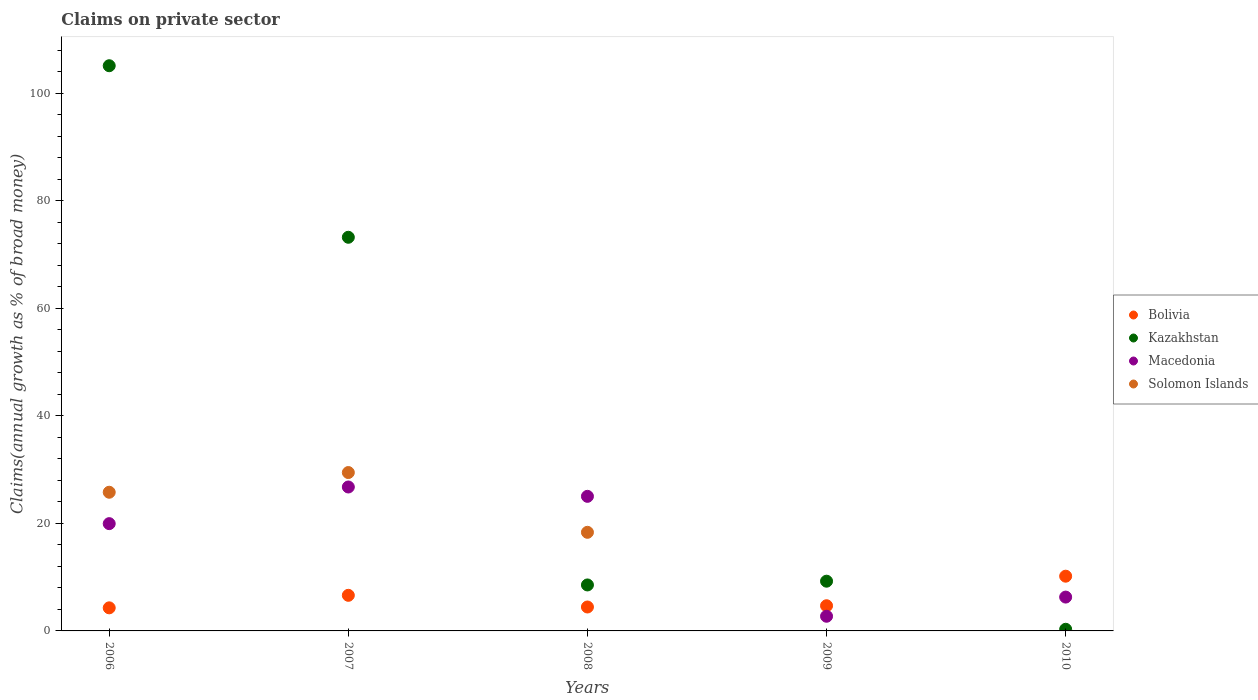How many different coloured dotlines are there?
Keep it short and to the point. 4. What is the percentage of broad money claimed on private sector in Solomon Islands in 2008?
Make the answer very short. 18.35. Across all years, what is the maximum percentage of broad money claimed on private sector in Macedonia?
Give a very brief answer. 26.78. Across all years, what is the minimum percentage of broad money claimed on private sector in Kazakhstan?
Your response must be concise. 0.31. What is the total percentage of broad money claimed on private sector in Solomon Islands in the graph?
Offer a terse response. 73.61. What is the difference between the percentage of broad money claimed on private sector in Macedonia in 2006 and that in 2008?
Your answer should be very brief. -5.08. What is the difference between the percentage of broad money claimed on private sector in Macedonia in 2006 and the percentage of broad money claimed on private sector in Kazakhstan in 2008?
Your response must be concise. 11.41. What is the average percentage of broad money claimed on private sector in Macedonia per year?
Give a very brief answer. 16.16. In the year 2007, what is the difference between the percentage of broad money claimed on private sector in Macedonia and percentage of broad money claimed on private sector in Kazakhstan?
Keep it short and to the point. -46.46. In how many years, is the percentage of broad money claimed on private sector in Solomon Islands greater than 16 %?
Make the answer very short. 3. What is the ratio of the percentage of broad money claimed on private sector in Kazakhstan in 2007 to that in 2008?
Your response must be concise. 8.56. What is the difference between the highest and the second highest percentage of broad money claimed on private sector in Kazakhstan?
Your response must be concise. 31.92. What is the difference between the highest and the lowest percentage of broad money claimed on private sector in Kazakhstan?
Provide a succinct answer. 104.85. Is the sum of the percentage of broad money claimed on private sector in Macedonia in 2007 and 2010 greater than the maximum percentage of broad money claimed on private sector in Kazakhstan across all years?
Your answer should be compact. No. Is it the case that in every year, the sum of the percentage of broad money claimed on private sector in Macedonia and percentage of broad money claimed on private sector in Solomon Islands  is greater than the sum of percentage of broad money claimed on private sector in Kazakhstan and percentage of broad money claimed on private sector in Bolivia?
Offer a terse response. No. Does the percentage of broad money claimed on private sector in Bolivia monotonically increase over the years?
Your answer should be compact. No. How many dotlines are there?
Give a very brief answer. 4. How many years are there in the graph?
Provide a succinct answer. 5. Are the values on the major ticks of Y-axis written in scientific E-notation?
Provide a succinct answer. No. Does the graph contain any zero values?
Your response must be concise. Yes. Where does the legend appear in the graph?
Your response must be concise. Center right. How many legend labels are there?
Keep it short and to the point. 4. How are the legend labels stacked?
Keep it short and to the point. Vertical. What is the title of the graph?
Your answer should be very brief. Claims on private sector. What is the label or title of the Y-axis?
Your answer should be compact. Claims(annual growth as % of broad money). What is the Claims(annual growth as % of broad money) in Bolivia in 2006?
Your answer should be compact. 4.29. What is the Claims(annual growth as % of broad money) of Kazakhstan in 2006?
Your response must be concise. 105.15. What is the Claims(annual growth as % of broad money) of Macedonia in 2006?
Your answer should be very brief. 19.96. What is the Claims(annual growth as % of broad money) of Solomon Islands in 2006?
Make the answer very short. 25.8. What is the Claims(annual growth as % of broad money) of Bolivia in 2007?
Give a very brief answer. 6.62. What is the Claims(annual growth as % of broad money) in Kazakhstan in 2007?
Provide a succinct answer. 73.24. What is the Claims(annual growth as % of broad money) in Macedonia in 2007?
Ensure brevity in your answer.  26.78. What is the Claims(annual growth as % of broad money) of Solomon Islands in 2007?
Your response must be concise. 29.47. What is the Claims(annual growth as % of broad money) in Bolivia in 2008?
Your answer should be very brief. 4.45. What is the Claims(annual growth as % of broad money) of Kazakhstan in 2008?
Offer a terse response. 8.55. What is the Claims(annual growth as % of broad money) in Macedonia in 2008?
Offer a very short reply. 25.04. What is the Claims(annual growth as % of broad money) in Solomon Islands in 2008?
Give a very brief answer. 18.35. What is the Claims(annual growth as % of broad money) of Bolivia in 2009?
Your answer should be compact. 4.69. What is the Claims(annual growth as % of broad money) of Kazakhstan in 2009?
Your response must be concise. 9.25. What is the Claims(annual growth as % of broad money) of Macedonia in 2009?
Provide a short and direct response. 2.73. What is the Claims(annual growth as % of broad money) in Solomon Islands in 2009?
Your response must be concise. 0. What is the Claims(annual growth as % of broad money) of Bolivia in 2010?
Keep it short and to the point. 10.18. What is the Claims(annual growth as % of broad money) in Kazakhstan in 2010?
Ensure brevity in your answer.  0.31. What is the Claims(annual growth as % of broad money) in Macedonia in 2010?
Keep it short and to the point. 6.3. What is the Claims(annual growth as % of broad money) of Solomon Islands in 2010?
Make the answer very short. 0. Across all years, what is the maximum Claims(annual growth as % of broad money) in Bolivia?
Offer a terse response. 10.18. Across all years, what is the maximum Claims(annual growth as % of broad money) of Kazakhstan?
Keep it short and to the point. 105.15. Across all years, what is the maximum Claims(annual growth as % of broad money) in Macedonia?
Offer a very short reply. 26.78. Across all years, what is the maximum Claims(annual growth as % of broad money) in Solomon Islands?
Provide a short and direct response. 29.47. Across all years, what is the minimum Claims(annual growth as % of broad money) of Bolivia?
Provide a succinct answer. 4.29. Across all years, what is the minimum Claims(annual growth as % of broad money) of Kazakhstan?
Your answer should be very brief. 0.31. Across all years, what is the minimum Claims(annual growth as % of broad money) in Macedonia?
Your answer should be compact. 2.73. Across all years, what is the minimum Claims(annual growth as % of broad money) of Solomon Islands?
Your response must be concise. 0. What is the total Claims(annual growth as % of broad money) of Bolivia in the graph?
Your response must be concise. 30.24. What is the total Claims(annual growth as % of broad money) of Kazakhstan in the graph?
Provide a succinct answer. 196.5. What is the total Claims(annual growth as % of broad money) of Macedonia in the graph?
Keep it short and to the point. 80.8. What is the total Claims(annual growth as % of broad money) of Solomon Islands in the graph?
Offer a terse response. 73.61. What is the difference between the Claims(annual growth as % of broad money) of Bolivia in 2006 and that in 2007?
Your response must be concise. -2.33. What is the difference between the Claims(annual growth as % of broad money) in Kazakhstan in 2006 and that in 2007?
Ensure brevity in your answer.  31.92. What is the difference between the Claims(annual growth as % of broad money) of Macedonia in 2006 and that in 2007?
Offer a very short reply. -6.82. What is the difference between the Claims(annual growth as % of broad money) in Solomon Islands in 2006 and that in 2007?
Your answer should be very brief. -3.66. What is the difference between the Claims(annual growth as % of broad money) of Bolivia in 2006 and that in 2008?
Your answer should be compact. -0.16. What is the difference between the Claims(annual growth as % of broad money) of Kazakhstan in 2006 and that in 2008?
Offer a very short reply. 96.6. What is the difference between the Claims(annual growth as % of broad money) of Macedonia in 2006 and that in 2008?
Provide a succinct answer. -5.08. What is the difference between the Claims(annual growth as % of broad money) in Solomon Islands in 2006 and that in 2008?
Your response must be concise. 7.45. What is the difference between the Claims(annual growth as % of broad money) of Bolivia in 2006 and that in 2009?
Ensure brevity in your answer.  -0.39. What is the difference between the Claims(annual growth as % of broad money) of Kazakhstan in 2006 and that in 2009?
Your response must be concise. 95.9. What is the difference between the Claims(annual growth as % of broad money) in Macedonia in 2006 and that in 2009?
Provide a succinct answer. 17.23. What is the difference between the Claims(annual growth as % of broad money) of Bolivia in 2006 and that in 2010?
Provide a short and direct response. -5.89. What is the difference between the Claims(annual growth as % of broad money) of Kazakhstan in 2006 and that in 2010?
Your response must be concise. 104.85. What is the difference between the Claims(annual growth as % of broad money) of Macedonia in 2006 and that in 2010?
Offer a terse response. 13.66. What is the difference between the Claims(annual growth as % of broad money) of Bolivia in 2007 and that in 2008?
Offer a very short reply. 2.17. What is the difference between the Claims(annual growth as % of broad money) of Kazakhstan in 2007 and that in 2008?
Give a very brief answer. 64.68. What is the difference between the Claims(annual growth as % of broad money) in Macedonia in 2007 and that in 2008?
Your response must be concise. 1.74. What is the difference between the Claims(annual growth as % of broad money) of Solomon Islands in 2007 and that in 2008?
Provide a succinct answer. 11.12. What is the difference between the Claims(annual growth as % of broad money) of Bolivia in 2007 and that in 2009?
Offer a very short reply. 1.94. What is the difference between the Claims(annual growth as % of broad money) in Kazakhstan in 2007 and that in 2009?
Provide a short and direct response. 63.98. What is the difference between the Claims(annual growth as % of broad money) in Macedonia in 2007 and that in 2009?
Keep it short and to the point. 24.05. What is the difference between the Claims(annual growth as % of broad money) in Bolivia in 2007 and that in 2010?
Offer a very short reply. -3.56. What is the difference between the Claims(annual growth as % of broad money) in Kazakhstan in 2007 and that in 2010?
Provide a short and direct response. 72.93. What is the difference between the Claims(annual growth as % of broad money) of Macedonia in 2007 and that in 2010?
Give a very brief answer. 20.48. What is the difference between the Claims(annual growth as % of broad money) of Bolivia in 2008 and that in 2009?
Your answer should be very brief. -0.24. What is the difference between the Claims(annual growth as % of broad money) of Kazakhstan in 2008 and that in 2009?
Ensure brevity in your answer.  -0.7. What is the difference between the Claims(annual growth as % of broad money) in Macedonia in 2008 and that in 2009?
Your response must be concise. 22.31. What is the difference between the Claims(annual growth as % of broad money) of Bolivia in 2008 and that in 2010?
Ensure brevity in your answer.  -5.73. What is the difference between the Claims(annual growth as % of broad money) in Kazakhstan in 2008 and that in 2010?
Provide a succinct answer. 8.25. What is the difference between the Claims(annual growth as % of broad money) of Macedonia in 2008 and that in 2010?
Offer a terse response. 18.74. What is the difference between the Claims(annual growth as % of broad money) in Bolivia in 2009 and that in 2010?
Your response must be concise. -5.5. What is the difference between the Claims(annual growth as % of broad money) of Kazakhstan in 2009 and that in 2010?
Provide a short and direct response. 8.95. What is the difference between the Claims(annual growth as % of broad money) in Macedonia in 2009 and that in 2010?
Keep it short and to the point. -3.57. What is the difference between the Claims(annual growth as % of broad money) in Bolivia in 2006 and the Claims(annual growth as % of broad money) in Kazakhstan in 2007?
Make the answer very short. -68.94. What is the difference between the Claims(annual growth as % of broad money) in Bolivia in 2006 and the Claims(annual growth as % of broad money) in Macedonia in 2007?
Provide a short and direct response. -22.48. What is the difference between the Claims(annual growth as % of broad money) in Bolivia in 2006 and the Claims(annual growth as % of broad money) in Solomon Islands in 2007?
Your answer should be compact. -25.17. What is the difference between the Claims(annual growth as % of broad money) of Kazakhstan in 2006 and the Claims(annual growth as % of broad money) of Macedonia in 2007?
Your answer should be compact. 78.38. What is the difference between the Claims(annual growth as % of broad money) in Kazakhstan in 2006 and the Claims(annual growth as % of broad money) in Solomon Islands in 2007?
Keep it short and to the point. 75.69. What is the difference between the Claims(annual growth as % of broad money) of Macedonia in 2006 and the Claims(annual growth as % of broad money) of Solomon Islands in 2007?
Your answer should be very brief. -9.51. What is the difference between the Claims(annual growth as % of broad money) in Bolivia in 2006 and the Claims(annual growth as % of broad money) in Kazakhstan in 2008?
Offer a very short reply. -4.26. What is the difference between the Claims(annual growth as % of broad money) in Bolivia in 2006 and the Claims(annual growth as % of broad money) in Macedonia in 2008?
Offer a very short reply. -20.75. What is the difference between the Claims(annual growth as % of broad money) of Bolivia in 2006 and the Claims(annual growth as % of broad money) of Solomon Islands in 2008?
Your answer should be compact. -14.05. What is the difference between the Claims(annual growth as % of broad money) in Kazakhstan in 2006 and the Claims(annual growth as % of broad money) in Macedonia in 2008?
Ensure brevity in your answer.  80.11. What is the difference between the Claims(annual growth as % of broad money) in Kazakhstan in 2006 and the Claims(annual growth as % of broad money) in Solomon Islands in 2008?
Your answer should be very brief. 86.81. What is the difference between the Claims(annual growth as % of broad money) in Macedonia in 2006 and the Claims(annual growth as % of broad money) in Solomon Islands in 2008?
Make the answer very short. 1.61. What is the difference between the Claims(annual growth as % of broad money) of Bolivia in 2006 and the Claims(annual growth as % of broad money) of Kazakhstan in 2009?
Keep it short and to the point. -4.96. What is the difference between the Claims(annual growth as % of broad money) of Bolivia in 2006 and the Claims(annual growth as % of broad money) of Macedonia in 2009?
Provide a short and direct response. 1.56. What is the difference between the Claims(annual growth as % of broad money) of Kazakhstan in 2006 and the Claims(annual growth as % of broad money) of Macedonia in 2009?
Your answer should be very brief. 102.42. What is the difference between the Claims(annual growth as % of broad money) in Bolivia in 2006 and the Claims(annual growth as % of broad money) in Kazakhstan in 2010?
Your answer should be compact. 3.99. What is the difference between the Claims(annual growth as % of broad money) in Bolivia in 2006 and the Claims(annual growth as % of broad money) in Macedonia in 2010?
Offer a very short reply. -2. What is the difference between the Claims(annual growth as % of broad money) of Kazakhstan in 2006 and the Claims(annual growth as % of broad money) of Macedonia in 2010?
Keep it short and to the point. 98.86. What is the difference between the Claims(annual growth as % of broad money) in Bolivia in 2007 and the Claims(annual growth as % of broad money) in Kazakhstan in 2008?
Provide a short and direct response. -1.93. What is the difference between the Claims(annual growth as % of broad money) in Bolivia in 2007 and the Claims(annual growth as % of broad money) in Macedonia in 2008?
Give a very brief answer. -18.42. What is the difference between the Claims(annual growth as % of broad money) in Bolivia in 2007 and the Claims(annual growth as % of broad money) in Solomon Islands in 2008?
Your answer should be very brief. -11.72. What is the difference between the Claims(annual growth as % of broad money) of Kazakhstan in 2007 and the Claims(annual growth as % of broad money) of Macedonia in 2008?
Give a very brief answer. 48.2. What is the difference between the Claims(annual growth as % of broad money) of Kazakhstan in 2007 and the Claims(annual growth as % of broad money) of Solomon Islands in 2008?
Ensure brevity in your answer.  54.89. What is the difference between the Claims(annual growth as % of broad money) in Macedonia in 2007 and the Claims(annual growth as % of broad money) in Solomon Islands in 2008?
Your answer should be compact. 8.43. What is the difference between the Claims(annual growth as % of broad money) of Bolivia in 2007 and the Claims(annual growth as % of broad money) of Kazakhstan in 2009?
Give a very brief answer. -2.63. What is the difference between the Claims(annual growth as % of broad money) in Bolivia in 2007 and the Claims(annual growth as % of broad money) in Macedonia in 2009?
Your response must be concise. 3.89. What is the difference between the Claims(annual growth as % of broad money) of Kazakhstan in 2007 and the Claims(annual growth as % of broad money) of Macedonia in 2009?
Provide a succinct answer. 70.51. What is the difference between the Claims(annual growth as % of broad money) in Bolivia in 2007 and the Claims(annual growth as % of broad money) in Kazakhstan in 2010?
Provide a short and direct response. 6.32. What is the difference between the Claims(annual growth as % of broad money) of Bolivia in 2007 and the Claims(annual growth as % of broad money) of Macedonia in 2010?
Keep it short and to the point. 0.33. What is the difference between the Claims(annual growth as % of broad money) of Kazakhstan in 2007 and the Claims(annual growth as % of broad money) of Macedonia in 2010?
Your answer should be very brief. 66.94. What is the difference between the Claims(annual growth as % of broad money) in Bolivia in 2008 and the Claims(annual growth as % of broad money) in Kazakhstan in 2009?
Offer a very short reply. -4.8. What is the difference between the Claims(annual growth as % of broad money) in Bolivia in 2008 and the Claims(annual growth as % of broad money) in Macedonia in 2009?
Give a very brief answer. 1.72. What is the difference between the Claims(annual growth as % of broad money) in Kazakhstan in 2008 and the Claims(annual growth as % of broad money) in Macedonia in 2009?
Offer a terse response. 5.82. What is the difference between the Claims(annual growth as % of broad money) of Bolivia in 2008 and the Claims(annual growth as % of broad money) of Kazakhstan in 2010?
Make the answer very short. 4.15. What is the difference between the Claims(annual growth as % of broad money) in Bolivia in 2008 and the Claims(annual growth as % of broad money) in Macedonia in 2010?
Provide a short and direct response. -1.85. What is the difference between the Claims(annual growth as % of broad money) of Kazakhstan in 2008 and the Claims(annual growth as % of broad money) of Macedonia in 2010?
Your answer should be very brief. 2.26. What is the difference between the Claims(annual growth as % of broad money) in Bolivia in 2009 and the Claims(annual growth as % of broad money) in Kazakhstan in 2010?
Your answer should be compact. 4.38. What is the difference between the Claims(annual growth as % of broad money) of Bolivia in 2009 and the Claims(annual growth as % of broad money) of Macedonia in 2010?
Give a very brief answer. -1.61. What is the difference between the Claims(annual growth as % of broad money) of Kazakhstan in 2009 and the Claims(annual growth as % of broad money) of Macedonia in 2010?
Provide a short and direct response. 2.96. What is the average Claims(annual growth as % of broad money) of Bolivia per year?
Offer a very short reply. 6.05. What is the average Claims(annual growth as % of broad money) in Kazakhstan per year?
Ensure brevity in your answer.  39.3. What is the average Claims(annual growth as % of broad money) of Macedonia per year?
Your answer should be compact. 16.16. What is the average Claims(annual growth as % of broad money) of Solomon Islands per year?
Your answer should be compact. 14.72. In the year 2006, what is the difference between the Claims(annual growth as % of broad money) of Bolivia and Claims(annual growth as % of broad money) of Kazakhstan?
Your response must be concise. -100.86. In the year 2006, what is the difference between the Claims(annual growth as % of broad money) of Bolivia and Claims(annual growth as % of broad money) of Macedonia?
Ensure brevity in your answer.  -15.66. In the year 2006, what is the difference between the Claims(annual growth as % of broad money) in Bolivia and Claims(annual growth as % of broad money) in Solomon Islands?
Give a very brief answer. -21.51. In the year 2006, what is the difference between the Claims(annual growth as % of broad money) in Kazakhstan and Claims(annual growth as % of broad money) in Macedonia?
Give a very brief answer. 85.19. In the year 2006, what is the difference between the Claims(annual growth as % of broad money) in Kazakhstan and Claims(annual growth as % of broad money) in Solomon Islands?
Your answer should be compact. 79.35. In the year 2006, what is the difference between the Claims(annual growth as % of broad money) of Macedonia and Claims(annual growth as % of broad money) of Solomon Islands?
Give a very brief answer. -5.84. In the year 2007, what is the difference between the Claims(annual growth as % of broad money) in Bolivia and Claims(annual growth as % of broad money) in Kazakhstan?
Your answer should be compact. -66.61. In the year 2007, what is the difference between the Claims(annual growth as % of broad money) in Bolivia and Claims(annual growth as % of broad money) in Macedonia?
Offer a terse response. -20.15. In the year 2007, what is the difference between the Claims(annual growth as % of broad money) in Bolivia and Claims(annual growth as % of broad money) in Solomon Islands?
Your response must be concise. -22.84. In the year 2007, what is the difference between the Claims(annual growth as % of broad money) in Kazakhstan and Claims(annual growth as % of broad money) in Macedonia?
Your answer should be compact. 46.46. In the year 2007, what is the difference between the Claims(annual growth as % of broad money) in Kazakhstan and Claims(annual growth as % of broad money) in Solomon Islands?
Your answer should be very brief. 43.77. In the year 2007, what is the difference between the Claims(annual growth as % of broad money) in Macedonia and Claims(annual growth as % of broad money) in Solomon Islands?
Offer a terse response. -2.69. In the year 2008, what is the difference between the Claims(annual growth as % of broad money) of Bolivia and Claims(annual growth as % of broad money) of Kazakhstan?
Make the answer very short. -4.1. In the year 2008, what is the difference between the Claims(annual growth as % of broad money) in Bolivia and Claims(annual growth as % of broad money) in Macedonia?
Keep it short and to the point. -20.59. In the year 2008, what is the difference between the Claims(annual growth as % of broad money) in Bolivia and Claims(annual growth as % of broad money) in Solomon Islands?
Your response must be concise. -13.9. In the year 2008, what is the difference between the Claims(annual growth as % of broad money) in Kazakhstan and Claims(annual growth as % of broad money) in Macedonia?
Your answer should be compact. -16.49. In the year 2008, what is the difference between the Claims(annual growth as % of broad money) in Kazakhstan and Claims(annual growth as % of broad money) in Solomon Islands?
Provide a succinct answer. -9.79. In the year 2008, what is the difference between the Claims(annual growth as % of broad money) of Macedonia and Claims(annual growth as % of broad money) of Solomon Islands?
Give a very brief answer. 6.69. In the year 2009, what is the difference between the Claims(annual growth as % of broad money) of Bolivia and Claims(annual growth as % of broad money) of Kazakhstan?
Ensure brevity in your answer.  -4.57. In the year 2009, what is the difference between the Claims(annual growth as % of broad money) of Bolivia and Claims(annual growth as % of broad money) of Macedonia?
Keep it short and to the point. 1.96. In the year 2009, what is the difference between the Claims(annual growth as % of broad money) in Kazakhstan and Claims(annual growth as % of broad money) in Macedonia?
Your answer should be very brief. 6.52. In the year 2010, what is the difference between the Claims(annual growth as % of broad money) in Bolivia and Claims(annual growth as % of broad money) in Kazakhstan?
Provide a succinct answer. 9.88. In the year 2010, what is the difference between the Claims(annual growth as % of broad money) of Bolivia and Claims(annual growth as % of broad money) of Macedonia?
Your answer should be compact. 3.89. In the year 2010, what is the difference between the Claims(annual growth as % of broad money) of Kazakhstan and Claims(annual growth as % of broad money) of Macedonia?
Provide a succinct answer. -5.99. What is the ratio of the Claims(annual growth as % of broad money) in Bolivia in 2006 to that in 2007?
Offer a very short reply. 0.65. What is the ratio of the Claims(annual growth as % of broad money) of Kazakhstan in 2006 to that in 2007?
Give a very brief answer. 1.44. What is the ratio of the Claims(annual growth as % of broad money) of Macedonia in 2006 to that in 2007?
Your answer should be compact. 0.75. What is the ratio of the Claims(annual growth as % of broad money) of Solomon Islands in 2006 to that in 2007?
Provide a short and direct response. 0.88. What is the ratio of the Claims(annual growth as % of broad money) in Bolivia in 2006 to that in 2008?
Make the answer very short. 0.96. What is the ratio of the Claims(annual growth as % of broad money) of Kazakhstan in 2006 to that in 2008?
Keep it short and to the point. 12.29. What is the ratio of the Claims(annual growth as % of broad money) of Macedonia in 2006 to that in 2008?
Provide a short and direct response. 0.8. What is the ratio of the Claims(annual growth as % of broad money) in Solomon Islands in 2006 to that in 2008?
Provide a short and direct response. 1.41. What is the ratio of the Claims(annual growth as % of broad money) in Bolivia in 2006 to that in 2009?
Keep it short and to the point. 0.92. What is the ratio of the Claims(annual growth as % of broad money) in Kazakhstan in 2006 to that in 2009?
Provide a succinct answer. 11.36. What is the ratio of the Claims(annual growth as % of broad money) in Macedonia in 2006 to that in 2009?
Your answer should be compact. 7.31. What is the ratio of the Claims(annual growth as % of broad money) in Bolivia in 2006 to that in 2010?
Make the answer very short. 0.42. What is the ratio of the Claims(annual growth as % of broad money) in Kazakhstan in 2006 to that in 2010?
Ensure brevity in your answer.  344.15. What is the ratio of the Claims(annual growth as % of broad money) in Macedonia in 2006 to that in 2010?
Your answer should be very brief. 3.17. What is the ratio of the Claims(annual growth as % of broad money) of Bolivia in 2007 to that in 2008?
Keep it short and to the point. 1.49. What is the ratio of the Claims(annual growth as % of broad money) in Kazakhstan in 2007 to that in 2008?
Keep it short and to the point. 8.56. What is the ratio of the Claims(annual growth as % of broad money) in Macedonia in 2007 to that in 2008?
Keep it short and to the point. 1.07. What is the ratio of the Claims(annual growth as % of broad money) in Solomon Islands in 2007 to that in 2008?
Your response must be concise. 1.61. What is the ratio of the Claims(annual growth as % of broad money) in Bolivia in 2007 to that in 2009?
Provide a short and direct response. 1.41. What is the ratio of the Claims(annual growth as % of broad money) in Kazakhstan in 2007 to that in 2009?
Provide a short and direct response. 7.92. What is the ratio of the Claims(annual growth as % of broad money) of Macedonia in 2007 to that in 2009?
Your answer should be very brief. 9.81. What is the ratio of the Claims(annual growth as % of broad money) of Bolivia in 2007 to that in 2010?
Ensure brevity in your answer.  0.65. What is the ratio of the Claims(annual growth as % of broad money) in Kazakhstan in 2007 to that in 2010?
Provide a short and direct response. 239.7. What is the ratio of the Claims(annual growth as % of broad money) in Macedonia in 2007 to that in 2010?
Ensure brevity in your answer.  4.25. What is the ratio of the Claims(annual growth as % of broad money) of Bolivia in 2008 to that in 2009?
Provide a succinct answer. 0.95. What is the ratio of the Claims(annual growth as % of broad money) in Kazakhstan in 2008 to that in 2009?
Ensure brevity in your answer.  0.92. What is the ratio of the Claims(annual growth as % of broad money) in Macedonia in 2008 to that in 2009?
Offer a very short reply. 9.17. What is the ratio of the Claims(annual growth as % of broad money) of Bolivia in 2008 to that in 2010?
Offer a very short reply. 0.44. What is the ratio of the Claims(annual growth as % of broad money) in Kazakhstan in 2008 to that in 2010?
Provide a short and direct response. 27.99. What is the ratio of the Claims(annual growth as % of broad money) in Macedonia in 2008 to that in 2010?
Make the answer very short. 3.98. What is the ratio of the Claims(annual growth as % of broad money) in Bolivia in 2009 to that in 2010?
Give a very brief answer. 0.46. What is the ratio of the Claims(annual growth as % of broad money) of Kazakhstan in 2009 to that in 2010?
Your answer should be compact. 30.28. What is the ratio of the Claims(annual growth as % of broad money) in Macedonia in 2009 to that in 2010?
Give a very brief answer. 0.43. What is the difference between the highest and the second highest Claims(annual growth as % of broad money) in Bolivia?
Your answer should be compact. 3.56. What is the difference between the highest and the second highest Claims(annual growth as % of broad money) of Kazakhstan?
Offer a terse response. 31.92. What is the difference between the highest and the second highest Claims(annual growth as % of broad money) in Macedonia?
Ensure brevity in your answer.  1.74. What is the difference between the highest and the second highest Claims(annual growth as % of broad money) of Solomon Islands?
Keep it short and to the point. 3.66. What is the difference between the highest and the lowest Claims(annual growth as % of broad money) in Bolivia?
Provide a succinct answer. 5.89. What is the difference between the highest and the lowest Claims(annual growth as % of broad money) of Kazakhstan?
Provide a succinct answer. 104.85. What is the difference between the highest and the lowest Claims(annual growth as % of broad money) of Macedonia?
Keep it short and to the point. 24.05. What is the difference between the highest and the lowest Claims(annual growth as % of broad money) of Solomon Islands?
Offer a very short reply. 29.47. 